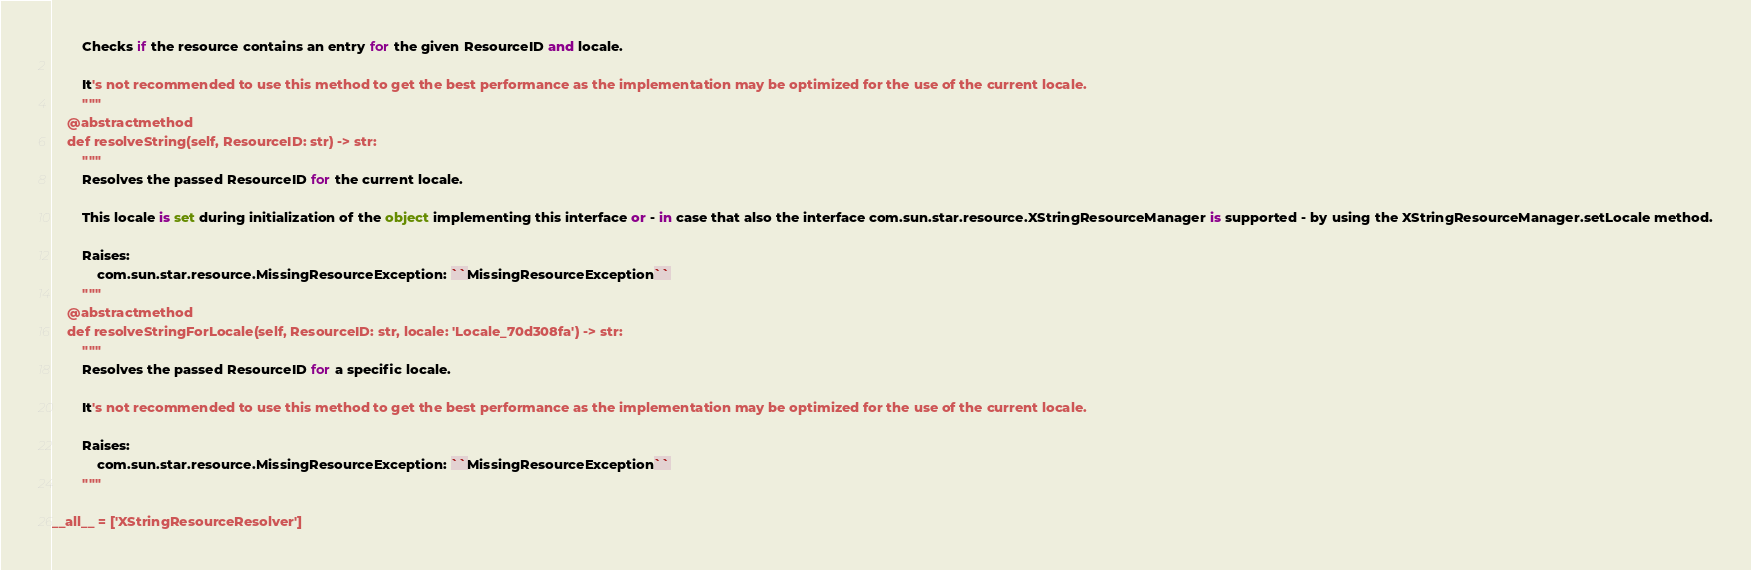<code> <loc_0><loc_0><loc_500><loc_500><_Python_>        Checks if the resource contains an entry for the given ResourceID and locale.
        
        It's not recommended to use this method to get the best performance as the implementation may be optimized for the use of the current locale.
        """
    @abstractmethod
    def resolveString(self, ResourceID: str) -> str:
        """
        Resolves the passed ResourceID for the current locale.
        
        This locale is set during initialization of the object implementing this interface or - in case that also the interface com.sun.star.resource.XStringResourceManager is supported - by using the XStringResourceManager.setLocale method.

        Raises:
            com.sun.star.resource.MissingResourceException: ``MissingResourceException``
        """
    @abstractmethod
    def resolveStringForLocale(self, ResourceID: str, locale: 'Locale_70d308fa') -> str:
        """
        Resolves the passed ResourceID for a specific locale.
        
        It's not recommended to use this method to get the best performance as the implementation may be optimized for the use of the current locale.

        Raises:
            com.sun.star.resource.MissingResourceException: ``MissingResourceException``
        """

__all__ = ['XStringResourceResolver']

</code> 